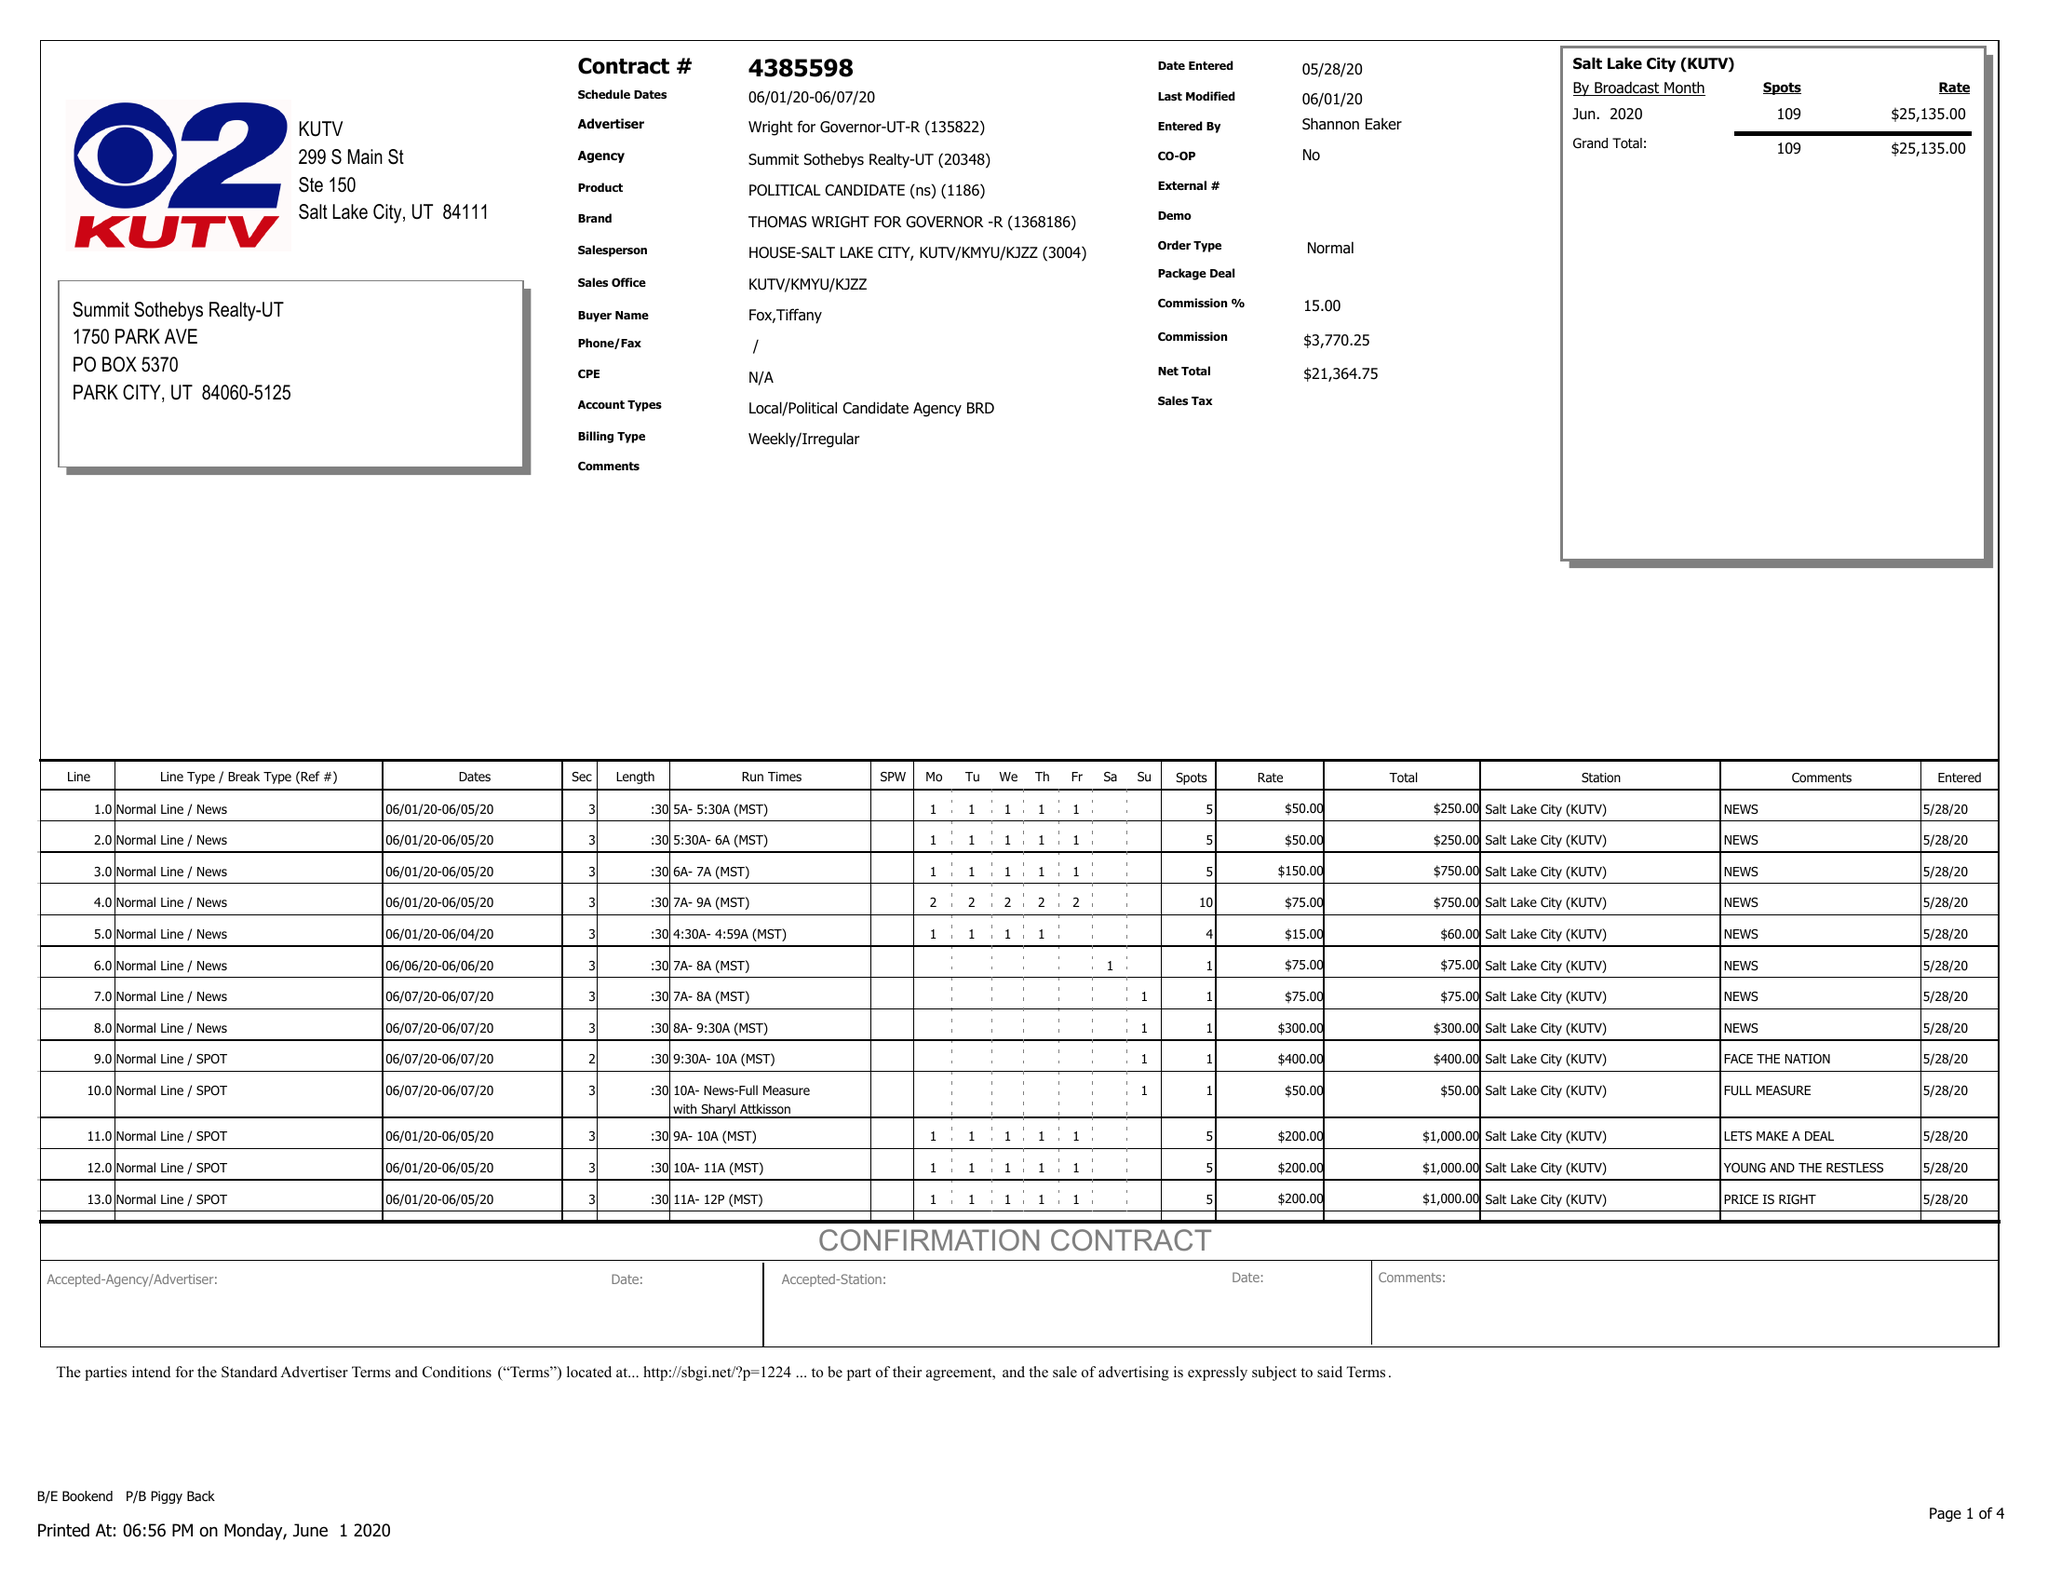What is the value for the advertiser?
Answer the question using a single word or phrase. WRIGHT FOR GOVERNOR-UT-R 